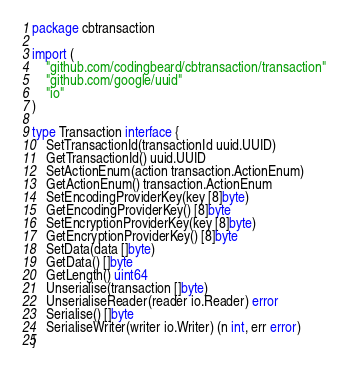<code> <loc_0><loc_0><loc_500><loc_500><_Go_>package cbtransaction

import (
	"github.com/codingbeard/cbtransaction/transaction"
	"github.com/google/uuid"
	"io"
)

type Transaction interface {
	SetTransactionId(transactionId uuid.UUID)
	GetTransactionId() uuid.UUID
	SetActionEnum(action transaction.ActionEnum)
	GetActionEnum() transaction.ActionEnum
	SetEncodingProviderKey(key [8]byte)
	GetEncodingProviderKey() [8]byte
	SetEncryptionProviderKey(key [8]byte)
	GetEncryptionProviderKey() [8]byte
	SetData(data []byte)
	GetData() []byte
	GetLength() uint64
	Unserialise(transaction []byte)
	UnserialiseReader(reader io.Reader) error
	Serialise() []byte
	SerialiseWriter(writer io.Writer) (n int, err error)
}
</code> 